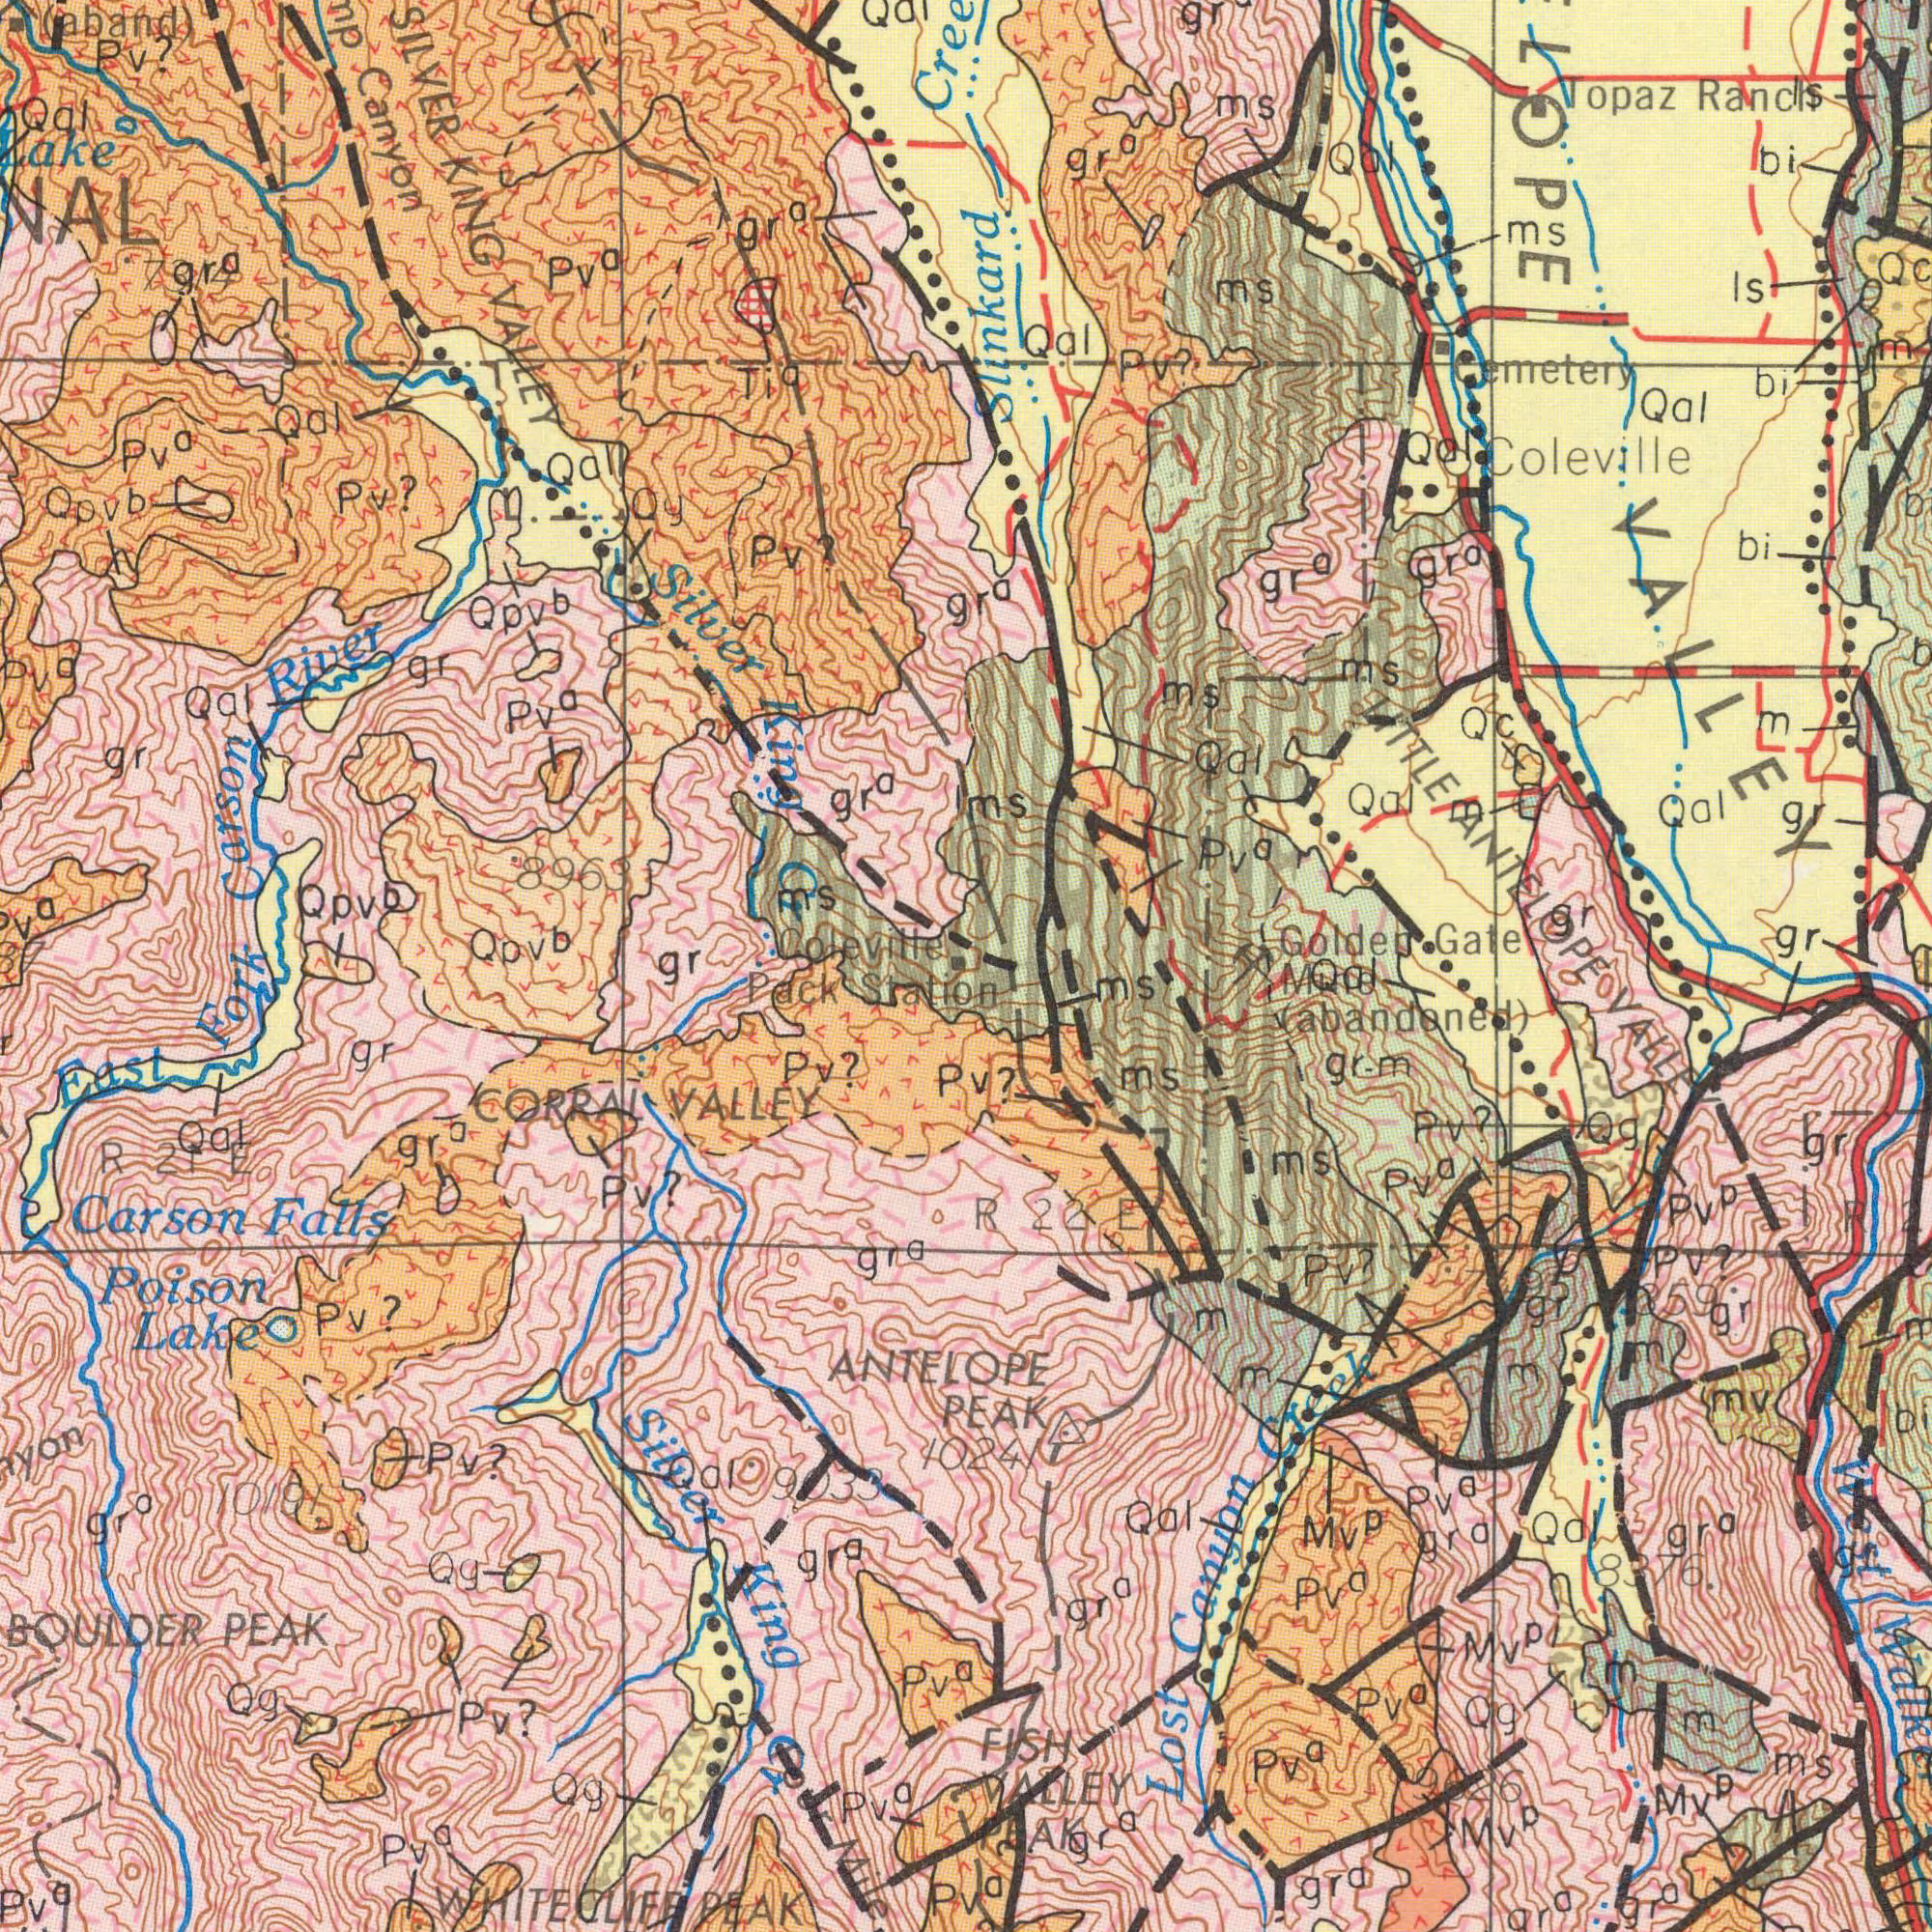What text appears in the top-left area of the image? Carson River Canyon SILVER KING VALLEY Lake Silver E Cr gr<sup>a</sup> (aband) Qal gr<sup>a</sup> Qpv<sup>b</sup> Qpv<sup>b</sup> Pv? Qpv<sup>b</sup> Qpv<sup>b</sup> gr gr MS Pv? Pv? Ti<sup>a</sup> pv<sup>a</sup> Coleville Pv<sup>a</sup> 8963 Qal Qal Qg Qal Pv<sup>a</sup> gr Pv<sup>a</sup> gr<sup>a</sup> Qal 7314 What text can you see in the bottom-right section? (abandoned) PEAK Pv<sup>a</sup> Pv? Mv<sup>p</sup> gr-m FISH VALLEY PEAK Mv<sup>p</sup> mv Pv<sup>a</sup> R 2 Qg Qal Mv<sup>p</sup> Mv<sup>p</sup> Mil ms gr ms ms gr gr Di Lost Canyon Creek Pv<sup>p</sup> Pv? ms Pv<sup>a</sup> Pv<sup>a</sup> gr<sup>a</sup> Pv<sup>a</sup> M 9626 R 22 E Pv? West Qal VALLEY M 8376. Qal gr<sup>a</sup> Pv<sup>a</sup> Qg gr<sup>a</sup> gr<sup>a</sup> gr<sup>a</sup> gr<sup>a</sup> 10241 M M Pv? M M m gr ###359 7495 Gr<sup>a</sup> What text can you see in the bottom-left section? East Fork Pack Station Poison Lake BOULDER PEAK Carson Falls ANTELOPE Silver King Cr Pv? WHITECLIFF PEAK CORRAL VALLEY Pv? R 21 E Pv<sup>a</sup> Pv? Pv? gr Qal gr<sup>a</sup> Pv<sup>a</sup> gr<sup>a</sup> Pv? 10191 Pv<sup>a</sup> Qg Pv<sup>a</sup> Qg gr<sup>a</sup> Qg Iour Mile gr<sup>a</sup> Qal 9033 What text appears in the top-right area of the image? Topaz Ranch Golden Gate Qal Qal ms IS Qal Cemetery Coleville Pv<sup>a</sup> ms ms ms bi LOPE VALLEY Qal bi gr MS Qal bi gr<sup>a</sup> M gr Qal QC Qc gr<sup>a</sup> LITTLE ANTELOPE Slinkard Pv? gr<sup>a</sup> gr<sup>a</sup> Qal M gr M Is MS gr<sup>a</sup> 